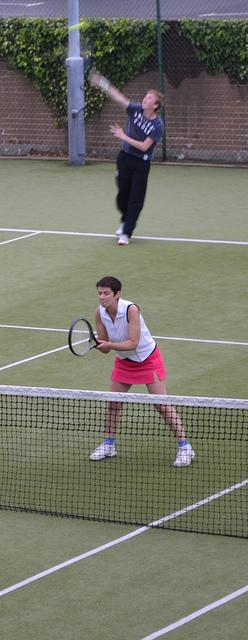What type of tennis are these two players playing?

Choices:
A) mixed doubles
B) men's doubles
C) woman's doubles
D) mixed ages mixed doubles 